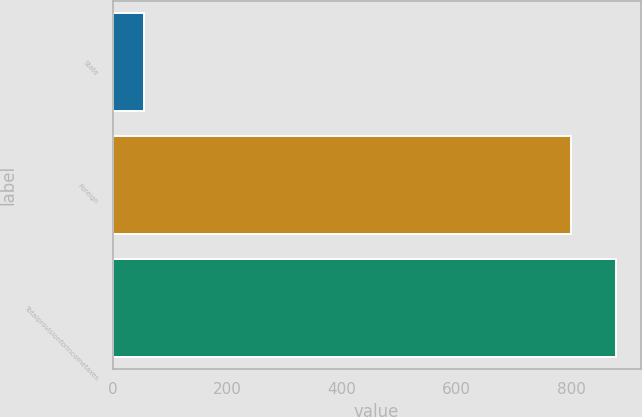Convert chart. <chart><loc_0><loc_0><loc_500><loc_500><bar_chart><fcel>State<fcel>Foreign<fcel>Totalprovisionforincometaxes<nl><fcel>55<fcel>800<fcel>877.3<nl></chart> 